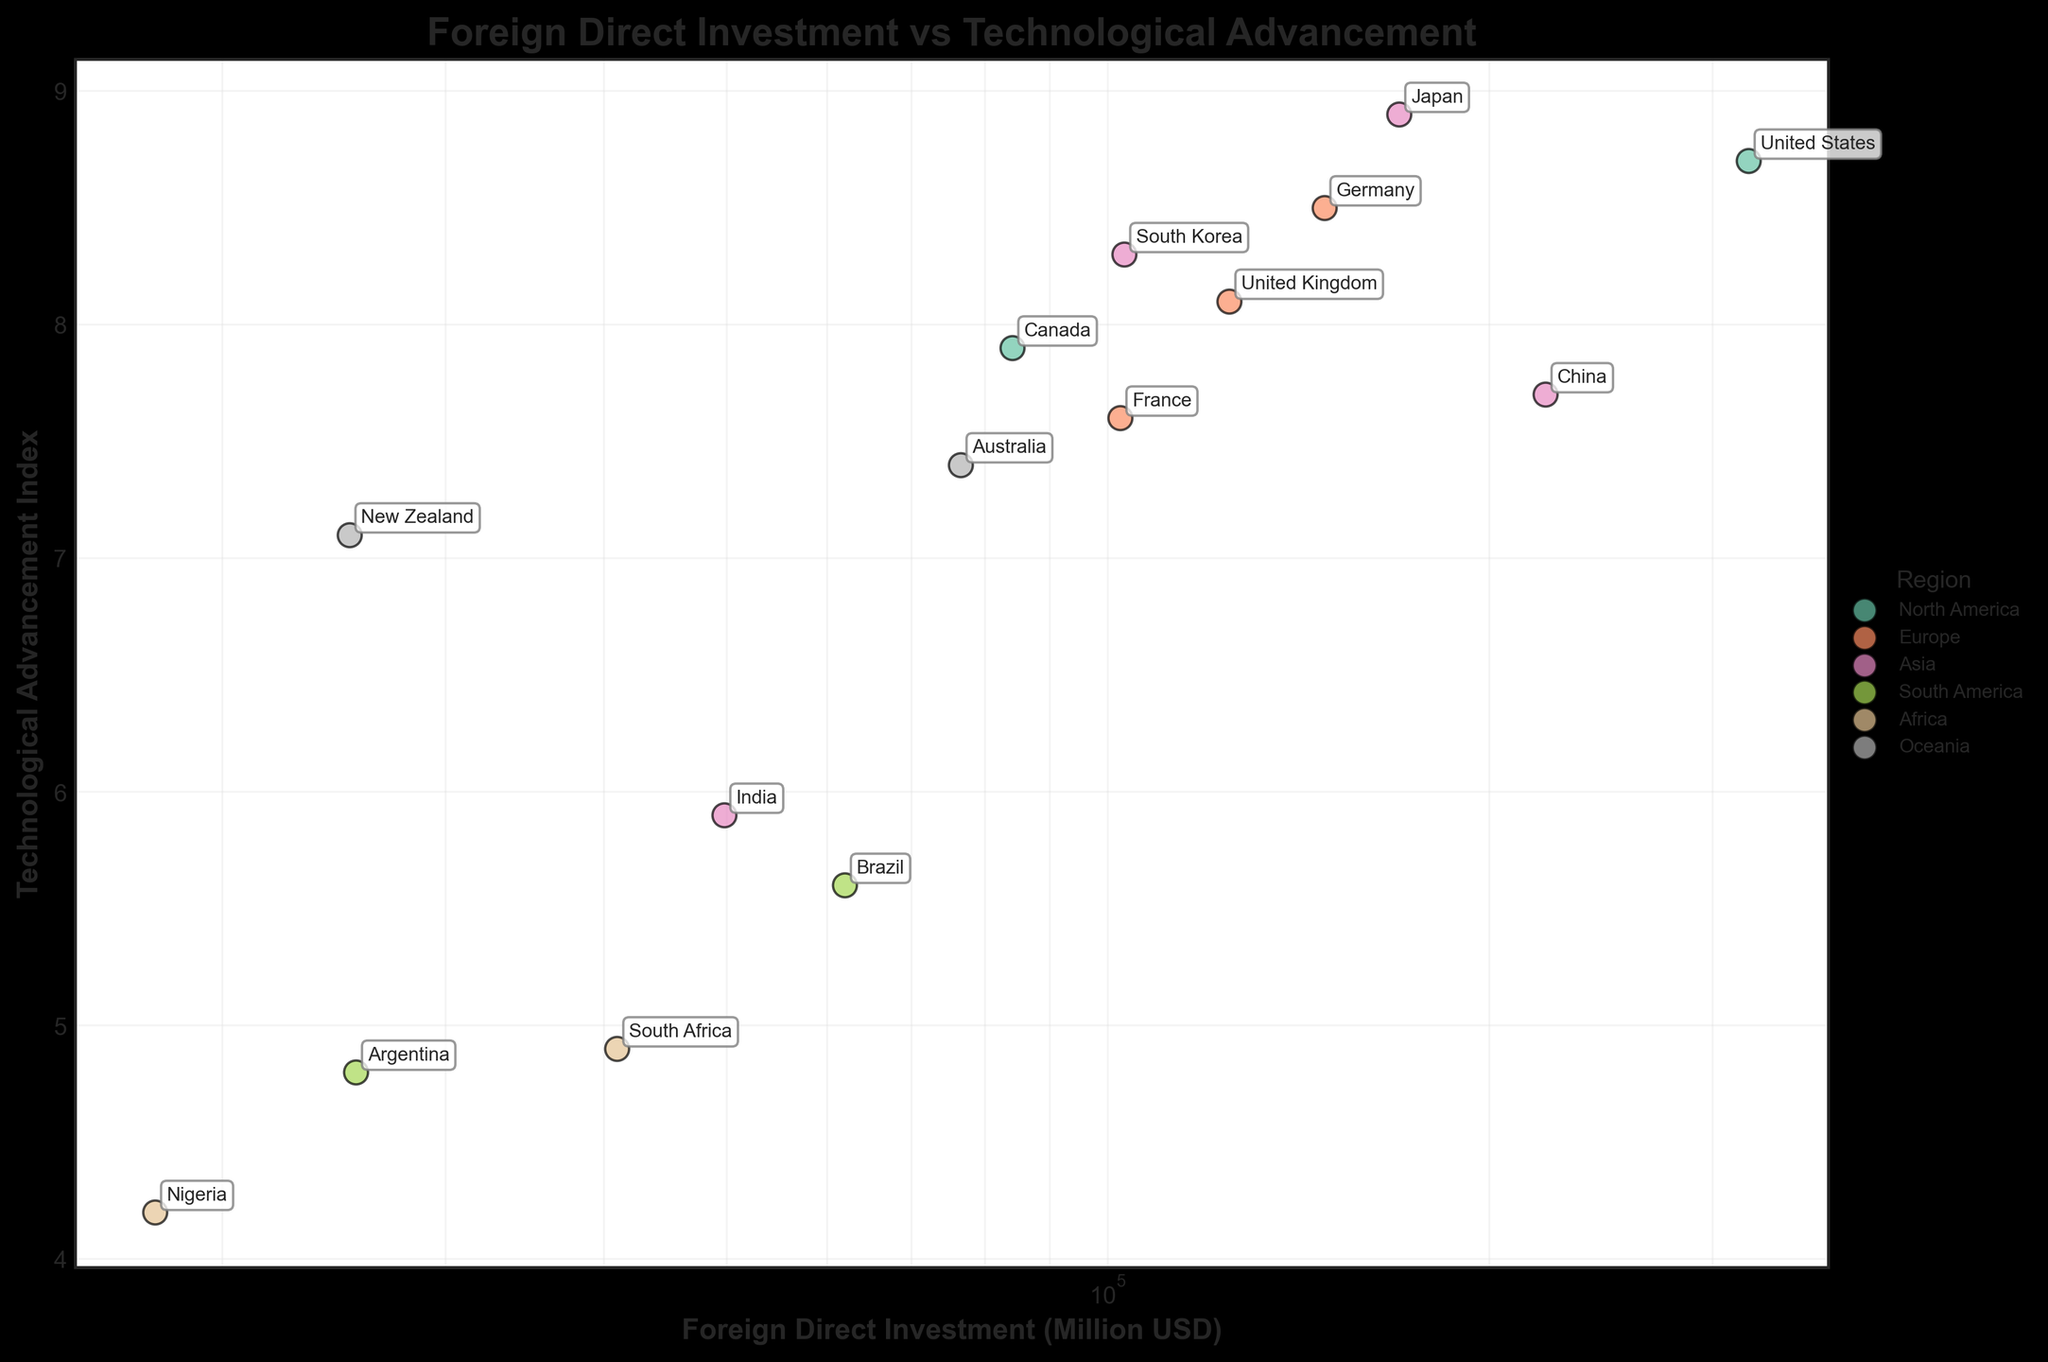What's the title of the figure? The title is usually displayed at the top of the figure. In this case, it reads "Foreign Direct Investment vs Technological Advancement."
Answer: Foreign Direct Investment vs Technological Advancement How many regions are represented in the figure? By looking at the legend in the figure, we can count the distinct regions listed. They are North America, Europe, Asia, South America, Africa, and Oceania.
Answer: 6 Which region has the country with the highest Foreign Direct Investment? The figure shows the highest Foreign Direct Investment data point labeled as the United States, which belongs to the North America region.
Answer: North America What is the approximate Technological Advancement Index for South Africa? Identify South Africa in the figure first, then check its vertical position on the y-axis. It is around 4.9.
Answer: 4.9 Which country in Asia has the highest Technological Advancement Index? Among the Asian countries marked on the plot, Japan has the highest Technological Advancement Index reaching 8.9.
Answer: Japan What is the range of the Foreign Direct Investment (FDI) values on the x-axis? The x-axis is on a log scale which means the range spans from lower to higher powers of 10. The smallest value for FDI is Nigeria with 17,700, and the largest is the United States with 320,400.
Answer: 17,700 to 320,400 Which country in South America has a higher Technological Advancement Index, Brazil or Argentina? Locate Brazil and Argentina on the plot and compare their y-axis values. Brazil is around 5.6 whereas Argentina is about 4.8. Hence, Brazil has a higher index.
Answer: Brazil What is the median Technological Advancement Index for the countries in Europe? The European countries listed are Germany (8.5), United Kingdom (8.1), and France (7.6). To find the median, we order them as 7.6, 8.1, 8.5. The middle value is 8.1.
Answer: 8.1 Is there any country with both low Foreign Direct Investment and low Technological Advancement Index, and if so, which one? Scan the bottom-left section of the plot where both values are low. Nigeria is positioned at the lower end of both axes with an FDI of 17,700 and Index of 4.2.
Answer: Nigeria 